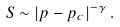Convert formula to latex. <formula><loc_0><loc_0><loc_500><loc_500>S \sim \left | p - p _ { c } \right | ^ { - \gamma } .</formula> 